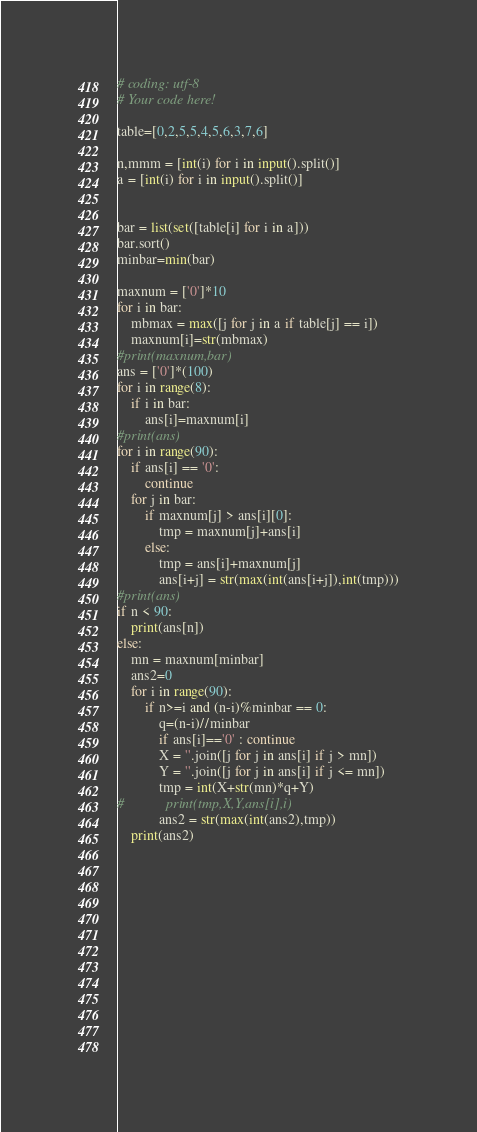<code> <loc_0><loc_0><loc_500><loc_500><_Python_># coding: utf-8
# Your code here!

table=[0,2,5,5,4,5,6,3,7,6]

n,mmm = [int(i) for i in input().split()]
a = [int(i) for i in input().split()]


bar = list(set([table[i] for i in a]))
bar.sort()
minbar=min(bar)

maxnum = ['0']*10
for i in bar:
    mbmax = max([j for j in a if table[j] == i])
    maxnum[i]=str(mbmax)
#print(maxnum,bar)
ans = ['0']*(100)
for i in range(8):
    if i in bar:
        ans[i]=maxnum[i]
#print(ans)
for i in range(90):
    if ans[i] == '0':
        continue
    for j in bar:
        if maxnum[j] > ans[i][0]:
            tmp = maxnum[j]+ans[i]
        else:
            tmp = ans[i]+maxnum[j]
            ans[i+j] = str(max(int(ans[i+j]),int(tmp)))
#print(ans)
if n < 90:
    print(ans[n])
else:
    mn = maxnum[minbar]
    ans2=0
    for i in range(90):
        if n>=i and (n-i)%minbar == 0:
            q=(n-i)//minbar
            if ans[i]=='0' : continue
            X = ''.join([j for j in ans[i] if j > mn])
            Y = ''.join([j for j in ans[i] if j <= mn])
            tmp = int(X+str(mn)*q+Y)
#            print(tmp,X,Y,ans[i],i)
            ans2 = str(max(int(ans2),tmp))
    print(ans2)
    

        
    
    
    
    


    
    

        
</code> 